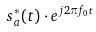<formula> <loc_0><loc_0><loc_500><loc_500>s _ { a } ^ { * } ( t ) \cdot e ^ { j 2 \pi f _ { 0 } t }</formula> 